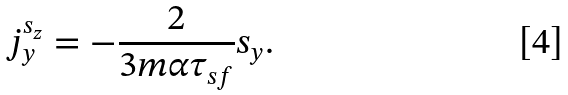<formula> <loc_0><loc_0><loc_500><loc_500>j ^ { s _ { z } } _ { y } = - \frac { 2 } { 3 m \alpha \tau _ { s f } } s _ { y } .</formula> 